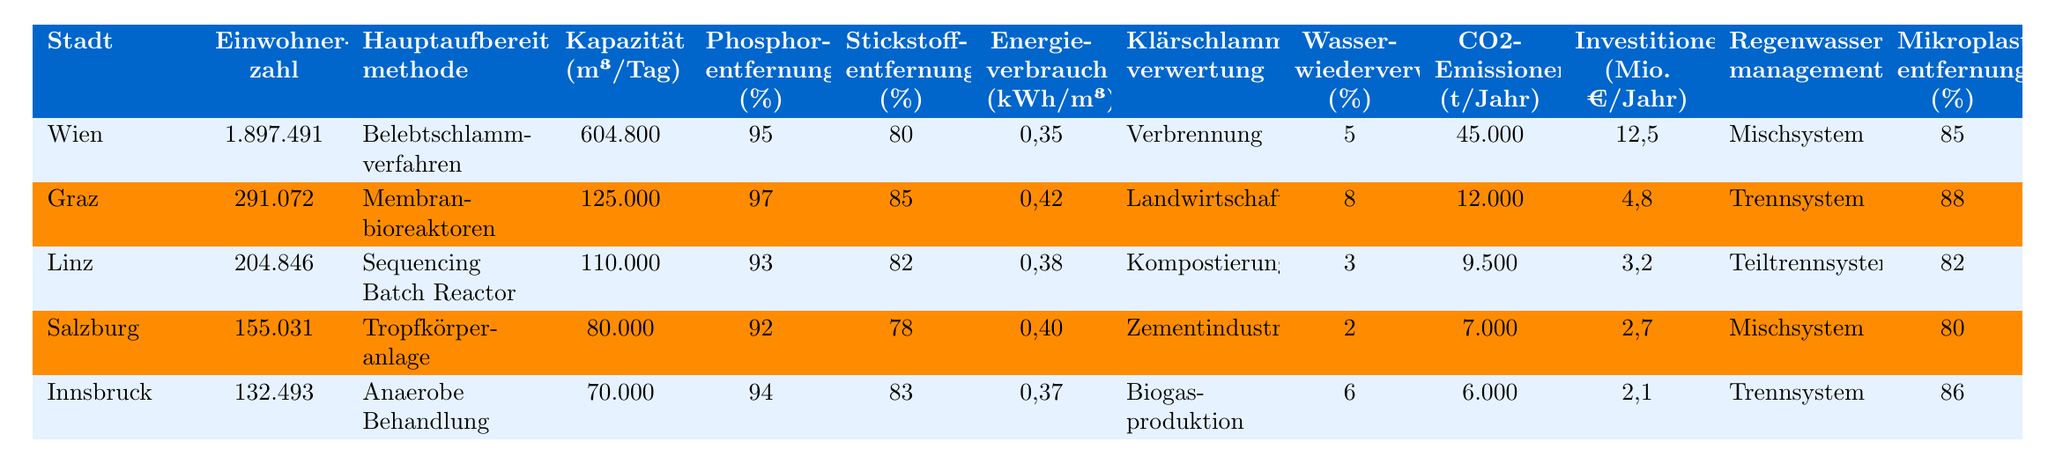Wie viele Einwohner hat Wien? Die Einwohnerzahl von Wien ist in der Tabelle direkt angegeben.
Answer: 1.897.491 Welche Hauptaufbereitungsmethode wird in Graz verwendet? Die Hauptaufbereitungsmethode für Graz ist ebenfalls in der Tabelle vermerkt.
Answer: Membranbioreaktoren Welches Stadt hat die höchste Phosphorentfernung (%)? Durch einen Vergleich der Phosphorentfernungswerte in der Tabelle ist zu erkennen, dass Graz mit 97 % den höchsten Wert hat.
Answer: Graz Was ist die durchschnittliche Stickstoffentfernung (%) der Städte? Die Stickstoffentfernung der Städte sind 80, 85, 82, 78, und 83. Der Durchschnitt wird berechnet, indem die Werte summiert und durch die Anzahl der Städte dividiert werden: (80 + 85 + 82 + 78 + 83) / 5 = 81.6.
Answer: 81.6 Wie viel CO2 emittiert Innsbruck pro Jahr? Die CO2-Emissionen für Innsbruck sind direkt in der Tabelle angegeben.
Answer: 6.000 t/Jahr Hat Salzburg eine höhere Wasserwiederverwendung (%) als Linz? In der Tabelle steht, dass Salzburg eine Wasserwiederverwendung von 2 % hat, während Linz 3 % hat. Das bedeutet, dass Linz mehr Wasser wiederverwendet.
Answer: Nein Welche Stadt hat die geringste Kapazität (m³/Tag)? Der Vergleich der Kapazitäten zeigt von Wien bis Innsbruck die Werte 604.800, 125.000, 110.000, 80.000 und 70.000. Innsbruck hat die geringste Kapazität.
Answer: Innsbruck Falls Wien seine Investitionen in neue Technologien um 10 % erhöht, wie viel würde dies in Millionen Euro pro Jahr betragen? Die aktuellen Investitionen in Wien betragen 12,5 Millionen Euro jährlich. Eine Erhöhung um 10 % wäre: 12,5 * 0,10 = 1,25 Millionen Euro. Die neuen Investitionen wären 12,5 + 1,25 = 13,75 Millionen Euro.
Answer: 13,75 Millionen Euro Welches Stadt hat den höchsten Energieverbrauch (kWh/m³)? Durch den Vergleich der Energieverbrauchswerte 0,35, 0,42, 0,38, 0,40 und 0,37 erkennt man, dass Graz mit 0,42 kWh/m³ den höchsten Energieverbrauch hat.
Answer: Graz Wie viel Klärschlammverwertung hat Wien im Vergleich zu Innsbruck? In der Tabelle steht, dass Wien Klärschlamm durch Verbrennung verwertet und Innsbruck durch Biogasproduktion. Da dies keine Prozentangabe ist, ist ein direkter Vergleich nicht möglich.
Answer: N/A Wie viel Prozent Mikroplastik wird in Salzburg entfernt? Der Wert für die Mikroplastikentfernung in Salzburg ist in der Tabelle aufgeführt.
Answer: 80 % 